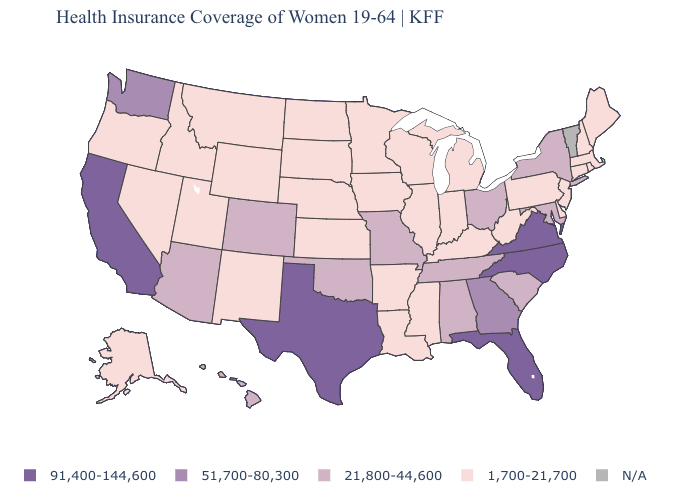Does Kentucky have the highest value in the USA?
Short answer required. No. Name the states that have a value in the range 91,400-144,600?
Quick response, please. California, Florida, North Carolina, Texas, Virginia. What is the value of New York?
Give a very brief answer. 21,800-44,600. Among the states that border Mississippi , which have the highest value?
Give a very brief answer. Alabama, Tennessee. Name the states that have a value in the range 21,800-44,600?
Quick response, please. Alabama, Arizona, Colorado, Hawaii, Maryland, Missouri, New York, Ohio, Oklahoma, South Carolina, Tennessee. Which states hav the highest value in the West?
Keep it brief. California. Does Rhode Island have the highest value in the Northeast?
Write a very short answer. No. What is the value of Nevada?
Give a very brief answer. 1,700-21,700. Does Washington have the highest value in the USA?
Write a very short answer. No. Is the legend a continuous bar?
Quick response, please. No. Which states hav the highest value in the MidWest?
Answer briefly. Missouri, Ohio. Does West Virginia have the lowest value in the South?
Concise answer only. Yes. Does Texas have the highest value in the South?
Keep it brief. Yes. 